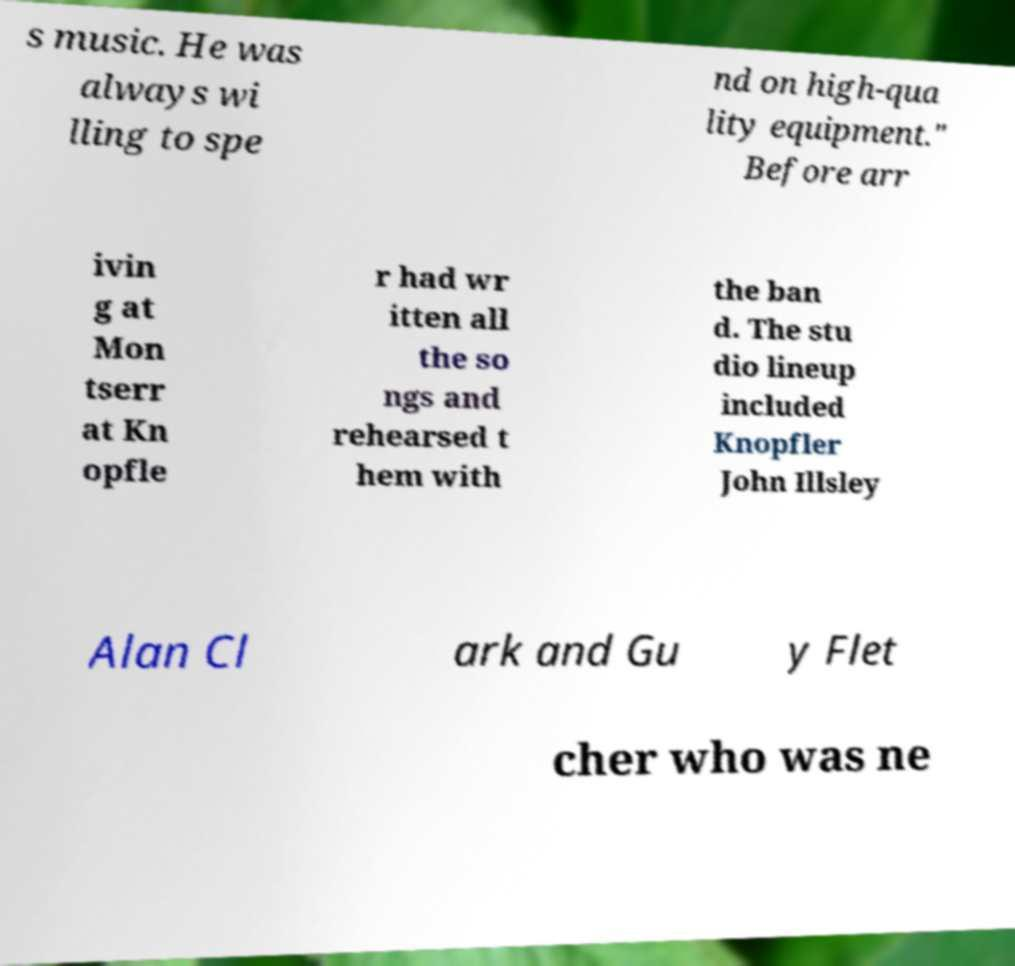Could you extract and type out the text from this image? s music. He was always wi lling to spe nd on high-qua lity equipment." Before arr ivin g at Mon tserr at Kn opfle r had wr itten all the so ngs and rehearsed t hem with the ban d. The stu dio lineup included Knopfler John Illsley Alan Cl ark and Gu y Flet cher who was ne 